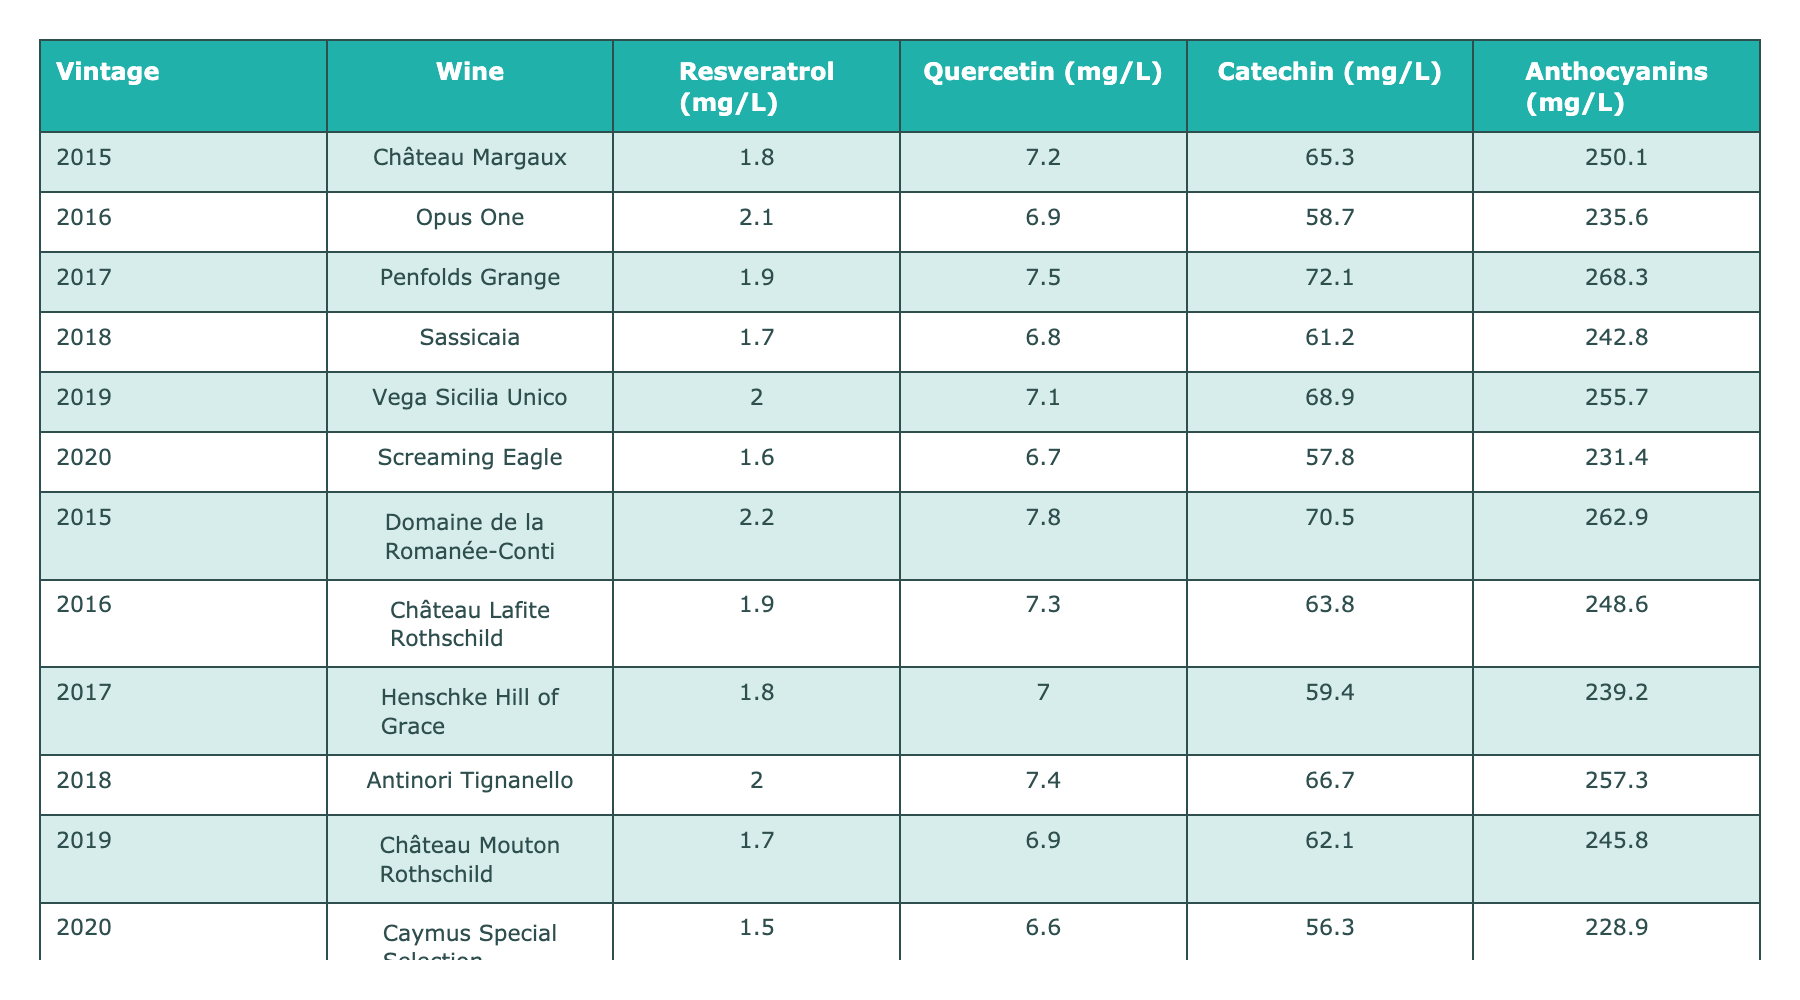What is the concentration of Resveratrol in Château Margaux from 2015? The table shows that the Resveratrol concentration for Château Margaux in 2015 is 1.8 mg/L.
Answer: 1.8 mg/L Which wine has the highest concentration of Catechin? By looking at the Catechin concentrations, Penfolds Grange from 2017 has the highest value at 72.1 mg/L.
Answer: Penfolds Grange (72.1 mg/L) What is the average concentration of Quercetin across all vintages? The Quercetin concentrations are 7.2, 6.9, 7.5, 6.8, 7.1, 6.7, 7.8, 7.3, 7.0, 7.4, 6.9, and 6.6 mg/L. Summing them gives 81.3 mg/L, which divided by 12 (the number of wines) gives an average of 6.775 mg/L.
Answer: 6.775 mg/L Which vintage had the highest concentration of Anthocyanins? The maximum concentration of Anthocyanins can be found by examining the values: 250.1, 235.6, 268.3, 242.8, 255.7, 231.4, 262.9, 248.6, 239.2, 257.3, 245.8, and 228.9 mg/L. The highest value is 268.3 mg/L in 2017 for Penfolds Grange.
Answer: 268.3 mg/L (2017) Is the concentration of Catechin in Screaming Eagle greater than the concentration of Catechin in Château Lafite Rothschild? Screaming Eagle has 57.8 mg/L of Catechin, while Château Lafite Rothschild has 63.8 mg/L. Since 57.8 < 63.8, the statement is false.
Answer: No What is the difference in Resveratrol concentration between Domaine de la Romanée-Conti 2015 and Caymus Special Selection 2020? Domaine de la Romanée-Conti has 2.2 mg/L and Caymus Special Selection has 1.5 mg/L. The difference is 2.2 - 1.5 = 0.7 mg/L.
Answer: 0.7 mg/L Which wine vintage had the lowest Anthocyanins concentration? By looking at the Anthocyanin concentrations, Caymus Special Selection 2020 is at the lowest with 228.9 mg/L.
Answer: Caymus Special Selection (228.9 mg/L, 2020) What is the total concentration of Resveratrol for all the wines from 2015? Adding the Resveratrol concentrations for 2015: 1.8 (Château Margaux) + 2.2 (Domaine de la Romanée-Conti) gives 4.0 mg/L in total.
Answer: 4.0 mg/L What wine had the highest Quercetin concentration in 2017? In 2017, Henschke Hill of Grace has 7.0 mg/L of Quercetin, while the other wines had 7.5 (Penfolds Grange). Penfolds Grange has the highest at 7.5 mg/L.
Answer: Penfolds Grange (7.5 mg/L) Compare the average Anthocyanins concentration for wines from 2015 and 2020. The Anthocyanins for 2015 are 250.1 (Château Margaux) + 262.9 (Domaine de la Romanée-Conti) = 513 mg/L for 2 wines or 256.5 mg/L on average. For 2020: 231.4 (Screaming Eagle) + 228.9 (Caymus Special Selection) = 460.3 mg/L for 2 wines or 230.15 mg/L on average. The average for 2015 is higher.
Answer: 2015 is higher (256.5 mg/L vs. 230.15 mg/L) 